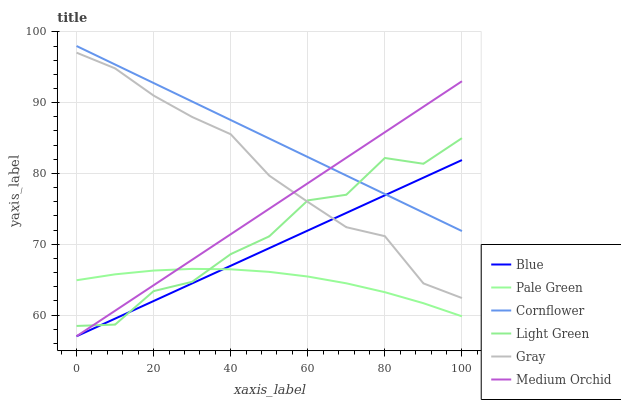Does Gray have the minimum area under the curve?
Answer yes or no. No. Does Gray have the maximum area under the curve?
Answer yes or no. No. Is Gray the smoothest?
Answer yes or no. No. Is Gray the roughest?
Answer yes or no. No. Does Gray have the lowest value?
Answer yes or no. No. Does Gray have the highest value?
Answer yes or no. No. Is Pale Green less than Cornflower?
Answer yes or no. Yes. Is Cornflower greater than Pale Green?
Answer yes or no. Yes. Does Pale Green intersect Cornflower?
Answer yes or no. No. 